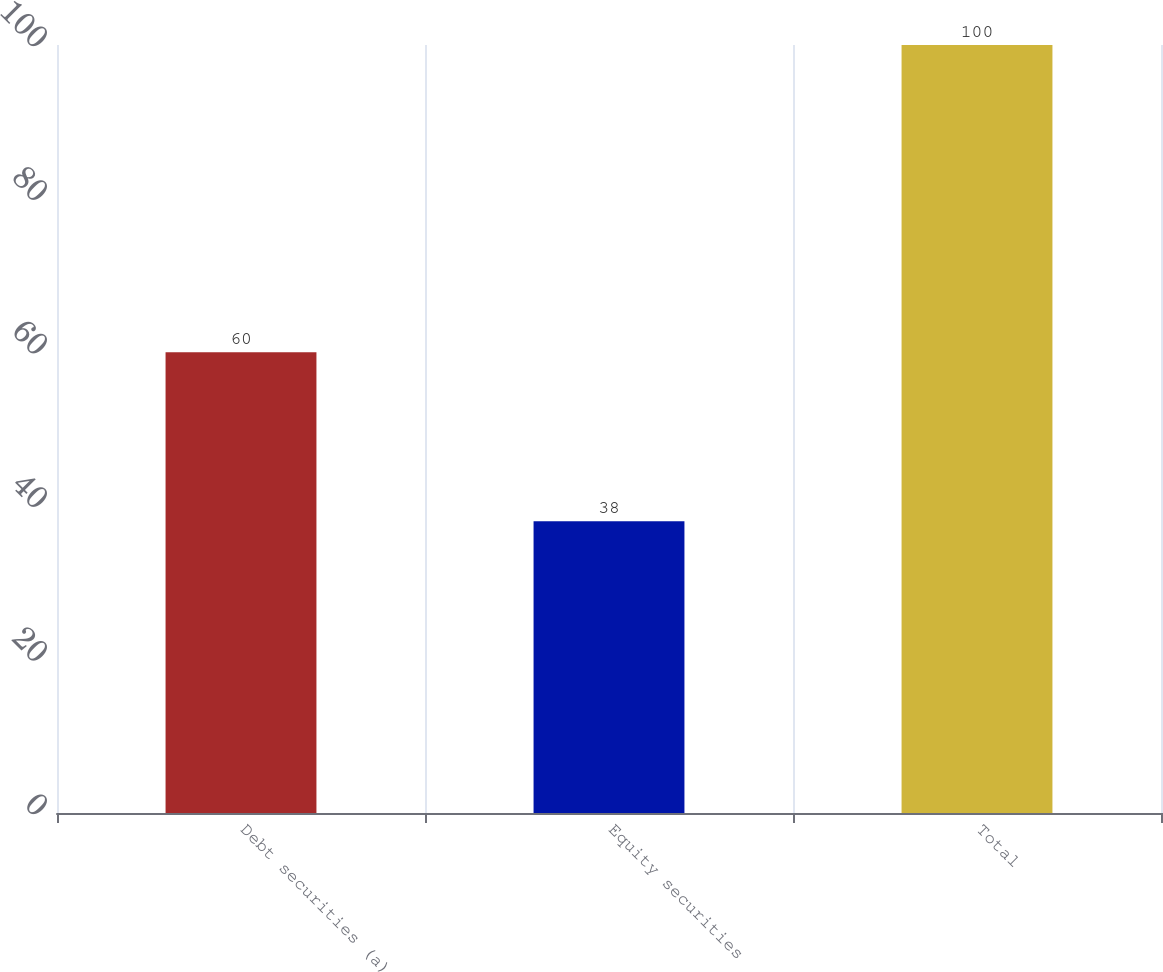Convert chart. <chart><loc_0><loc_0><loc_500><loc_500><bar_chart><fcel>Debt securities (a)<fcel>Equity securities<fcel>Total<nl><fcel>60<fcel>38<fcel>100<nl></chart> 